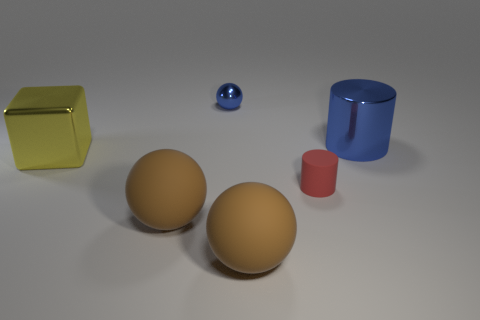Add 1 blue spheres. How many objects exist? 7 Subtract all cubes. How many objects are left? 5 Subtract all gray rubber spheres. Subtract all small cylinders. How many objects are left? 5 Add 3 tiny cylinders. How many tiny cylinders are left? 4 Add 1 shiny blocks. How many shiny blocks exist? 2 Subtract 0 yellow cylinders. How many objects are left? 6 